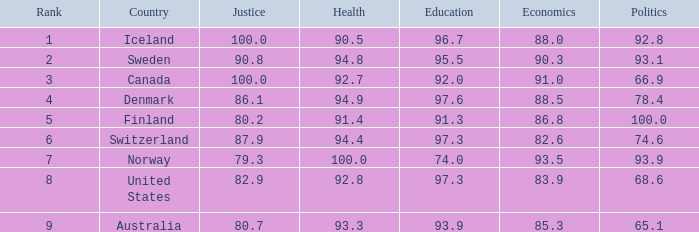What's the country with health being 91.4 Finland. 